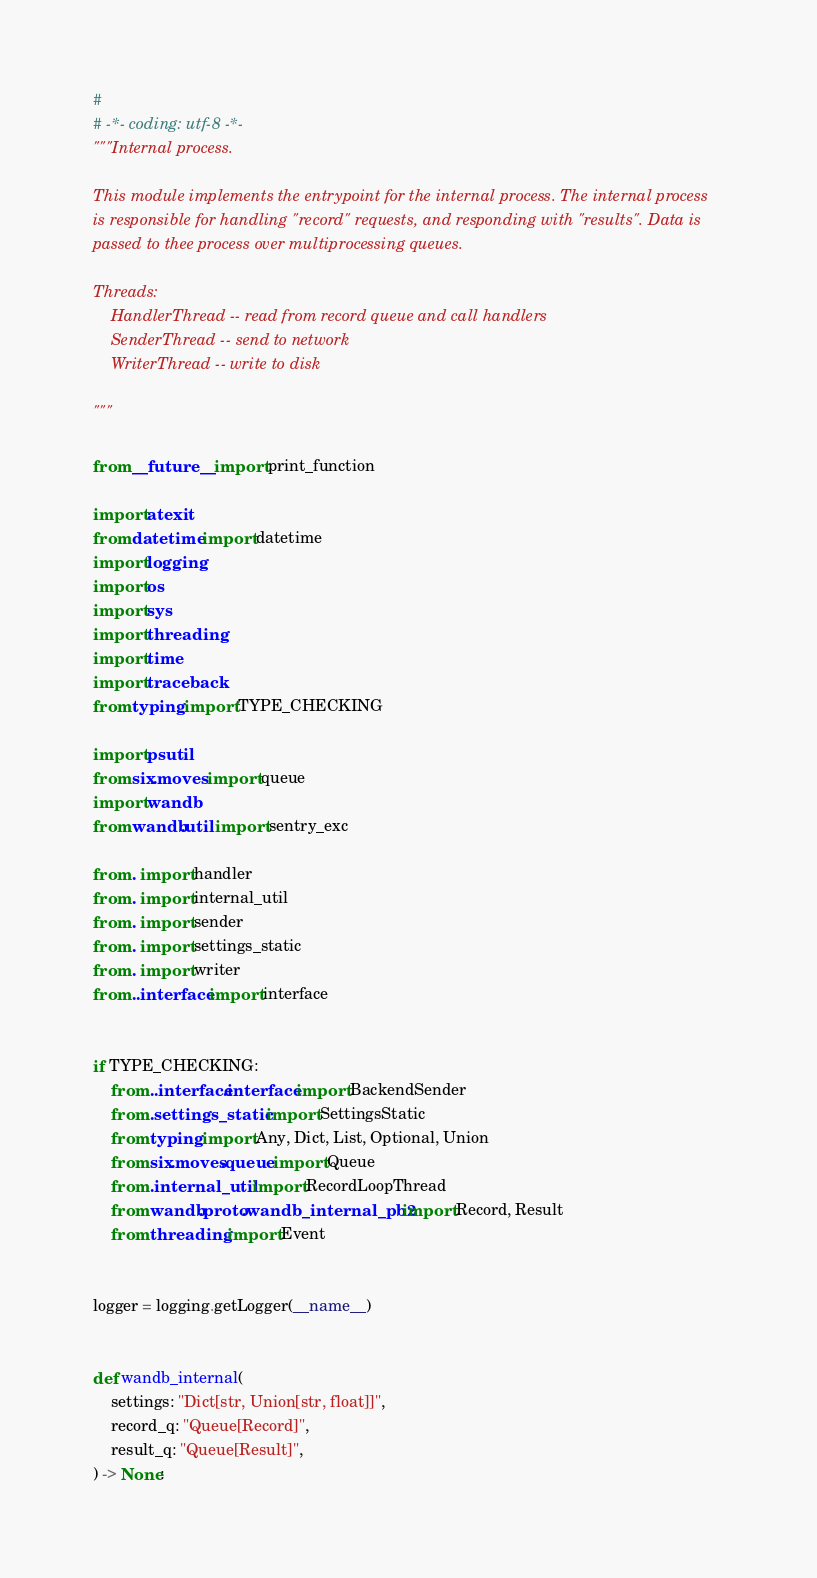<code> <loc_0><loc_0><loc_500><loc_500><_Python_>#
# -*- coding: utf-8 -*-
"""Internal process.

This module implements the entrypoint for the internal process. The internal process
is responsible for handling "record" requests, and responding with "results". Data is
passed to thee process over multiprocessing queues.

Threads:
    HandlerThread -- read from record queue and call handlers
    SenderThread -- send to network
    WriterThread -- write to disk

"""

from __future__ import print_function

import atexit
from datetime import datetime
import logging
import os
import sys
import threading
import time
import traceback
from typing import TYPE_CHECKING

import psutil
from six.moves import queue
import wandb
from wandb.util import sentry_exc

from . import handler
from . import internal_util
from . import sender
from . import settings_static
from . import writer
from ..interface import interface


if TYPE_CHECKING:
    from ..interface.interface import BackendSender
    from .settings_static import SettingsStatic
    from typing import Any, Dict, List, Optional, Union
    from six.moves.queue import Queue
    from .internal_util import RecordLoopThread
    from wandb.proto.wandb_internal_pb2 import Record, Result
    from threading import Event


logger = logging.getLogger(__name__)


def wandb_internal(
    settings: "Dict[str, Union[str, float]]",
    record_q: "Queue[Record]",
    result_q: "Queue[Result]",
) -> None:</code> 